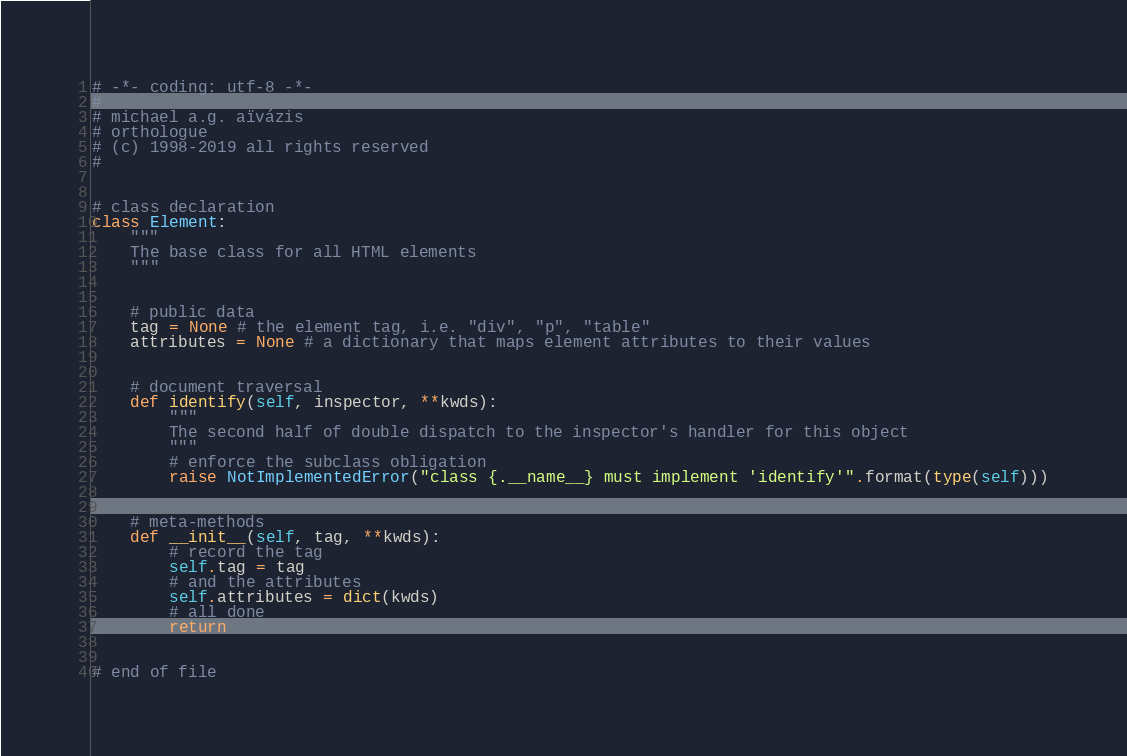Convert code to text. <code><loc_0><loc_0><loc_500><loc_500><_Python_># -*- coding: utf-8 -*-
#
# michael a.g. aïvázis
# orthologue
# (c) 1998-2019 all rights reserved
#


# class declaration
class Element:
    """
    The base class for all HTML elements
    """


    # public data
    tag = None # the element tag, i.e. "div", "p", "table"
    attributes = None # a dictionary that maps element attributes to their values


    # document traversal
    def identify(self, inspector, **kwds):
        """
        The second half of double dispatch to the inspector's handler for this object
        """
        # enforce the subclass obligation
        raise NotImplementedError("class {.__name__} must implement 'identify'".format(type(self)))


    # meta-methods
    def __init__(self, tag, **kwds):
        # record the tag
        self.tag = tag
        # and the attributes
        self.attributes = dict(kwds)
        # all done
        return


# end of file
</code> 